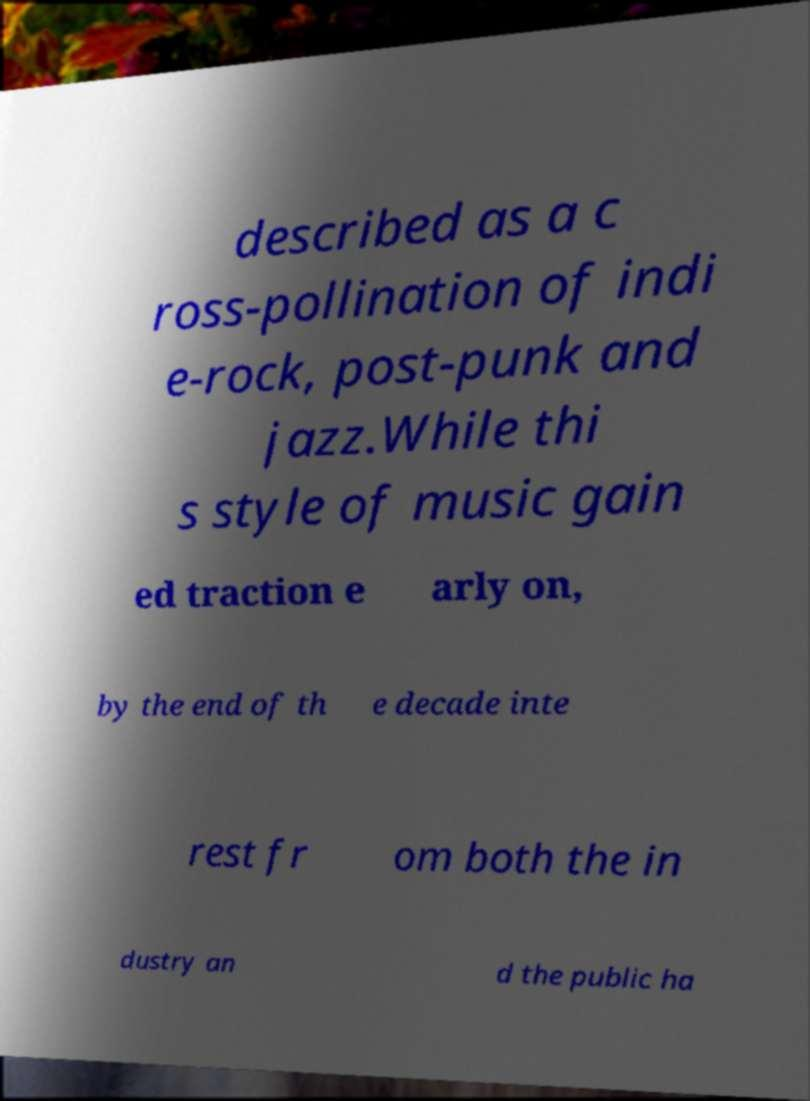Could you assist in decoding the text presented in this image and type it out clearly? described as a c ross-pollination of indi e-rock, post-punk and jazz.While thi s style of music gain ed traction e arly on, by the end of th e decade inte rest fr om both the in dustry an d the public ha 